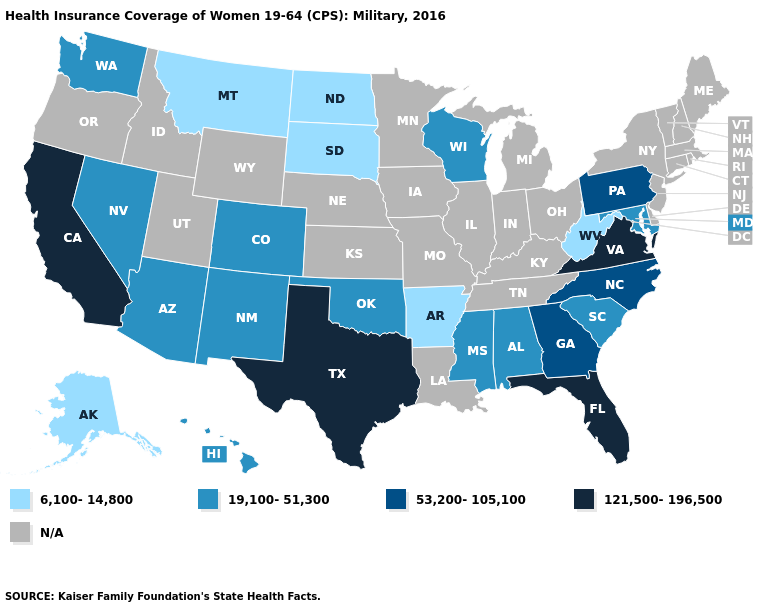What is the value of Vermont?
Keep it brief. N/A. What is the highest value in the Northeast ?
Quick response, please. 53,200-105,100. Name the states that have a value in the range 6,100-14,800?
Concise answer only. Alaska, Arkansas, Montana, North Dakota, South Dakota, West Virginia. Name the states that have a value in the range N/A?
Write a very short answer. Connecticut, Delaware, Idaho, Illinois, Indiana, Iowa, Kansas, Kentucky, Louisiana, Maine, Massachusetts, Michigan, Minnesota, Missouri, Nebraska, New Hampshire, New Jersey, New York, Ohio, Oregon, Rhode Island, Tennessee, Utah, Vermont, Wyoming. Name the states that have a value in the range 121,500-196,500?
Keep it brief. California, Florida, Texas, Virginia. Name the states that have a value in the range 121,500-196,500?
Concise answer only. California, Florida, Texas, Virginia. Which states have the lowest value in the USA?
Be succinct. Alaska, Arkansas, Montana, North Dakota, South Dakota, West Virginia. Which states hav the highest value in the Northeast?
Give a very brief answer. Pennsylvania. Does Colorado have the highest value in the USA?
Answer briefly. No. What is the value of Ohio?
Be succinct. N/A. Name the states that have a value in the range 6,100-14,800?
Be succinct. Alaska, Arkansas, Montana, North Dakota, South Dakota, West Virginia. What is the highest value in the Northeast ?
Keep it brief. 53,200-105,100. Does North Dakota have the lowest value in the USA?
Concise answer only. Yes. 